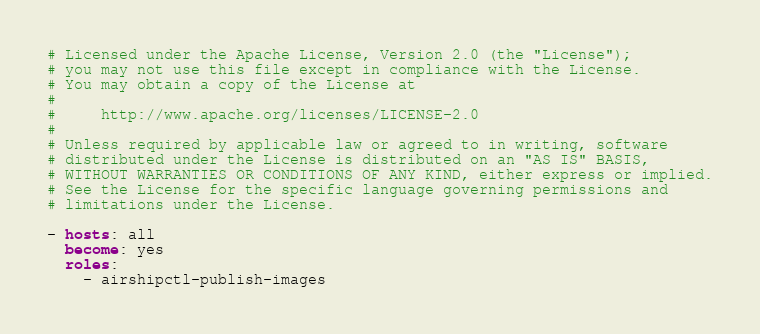Convert code to text. <code><loc_0><loc_0><loc_500><loc_500><_YAML_># Licensed under the Apache License, Version 2.0 (the "License");
# you may not use this file except in compliance with the License.
# You may obtain a copy of the License at
#
#     http://www.apache.org/licenses/LICENSE-2.0
#
# Unless required by applicable law or agreed to in writing, software
# distributed under the License is distributed on an "AS IS" BASIS,
# WITHOUT WARRANTIES OR CONDITIONS OF ANY KIND, either express or implied.
# See the License for the specific language governing permissions and
# limitations under the License.

- hosts: all
  become: yes
  roles:
    - airshipctl-publish-images
</code> 